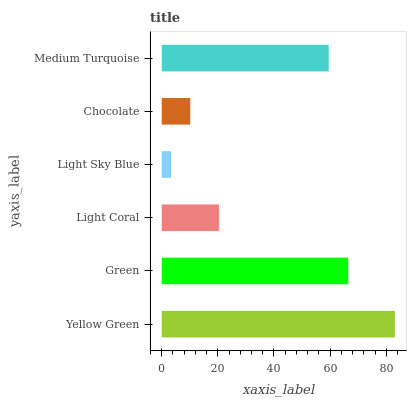Is Light Sky Blue the minimum?
Answer yes or no. Yes. Is Yellow Green the maximum?
Answer yes or no. Yes. Is Green the minimum?
Answer yes or no. No. Is Green the maximum?
Answer yes or no. No. Is Yellow Green greater than Green?
Answer yes or no. Yes. Is Green less than Yellow Green?
Answer yes or no. Yes. Is Green greater than Yellow Green?
Answer yes or no. No. Is Yellow Green less than Green?
Answer yes or no. No. Is Medium Turquoise the high median?
Answer yes or no. Yes. Is Light Coral the low median?
Answer yes or no. Yes. Is Yellow Green the high median?
Answer yes or no. No. Is Medium Turquoise the low median?
Answer yes or no. No. 